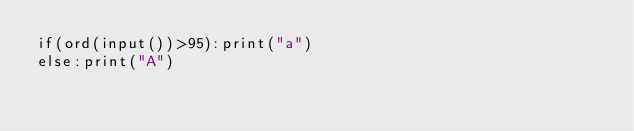<code> <loc_0><loc_0><loc_500><loc_500><_Python_>if(ord(input())>95):print("a")
else:print("A")</code> 